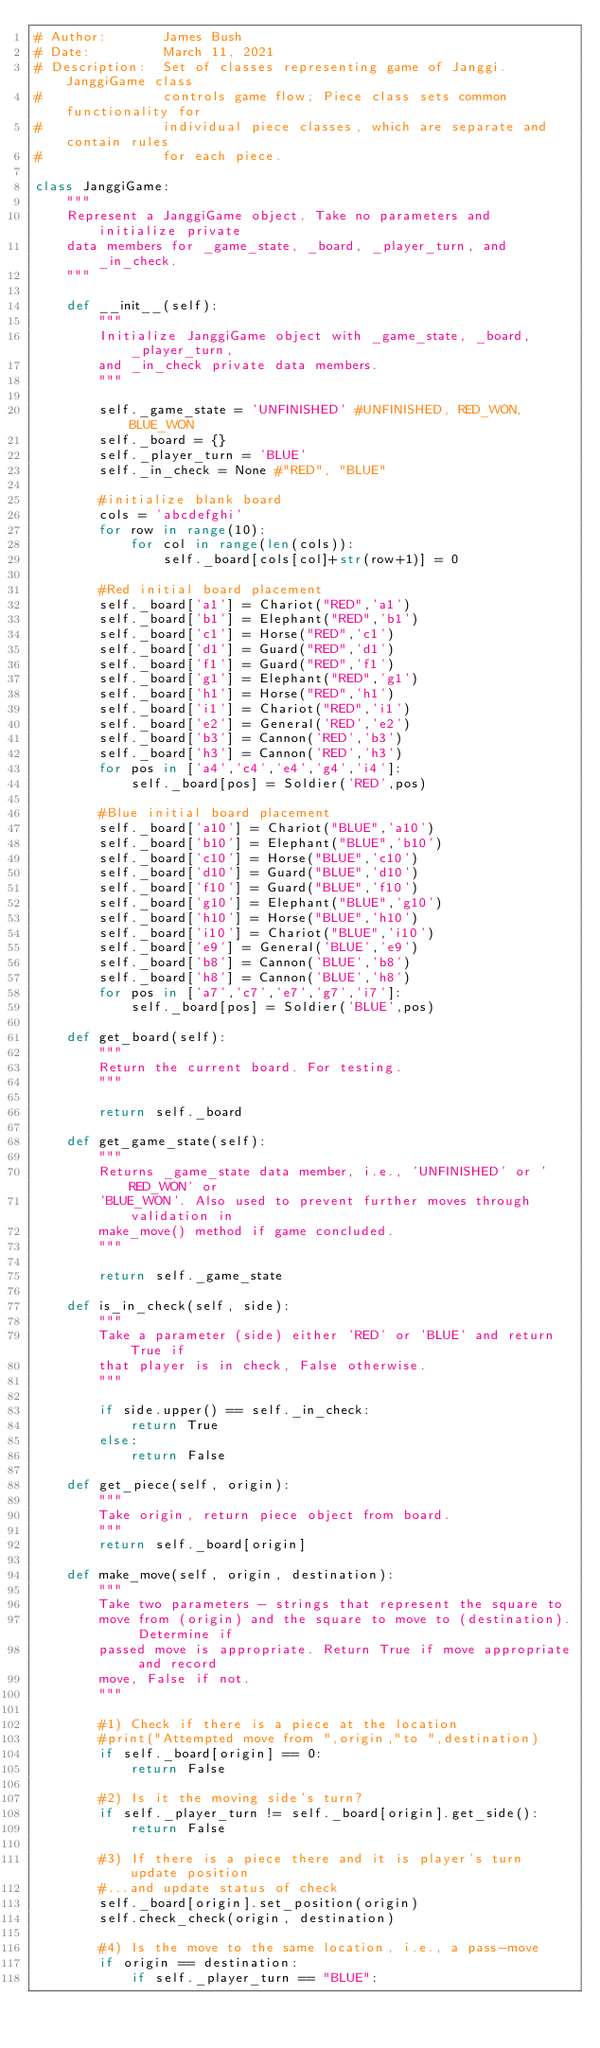Convert code to text. <code><loc_0><loc_0><loc_500><loc_500><_Python_># Author:       James Bush
# Date:         March 11, 2021
# Description:  Set of classes representing game of Janggi. JanggiGame class
#               controls game flow; Piece class sets common functionality for
#               individual piece classes, which are separate and contain rules
#               for each piece.

class JanggiGame:
    """
    Represent a JanggiGame object. Take no parameters and initialize private
    data members for _game_state, _board, _player_turn, and _in_check.
    """

    def __init__(self):
        """
        Initialize JanggiGame object with _game_state, _board, _player_turn,
        and _in_check private data members.
        """

        self._game_state = 'UNFINISHED' #UNFINISHED, RED_WON, BLUE_WON
        self._board = {}
        self._player_turn = 'BLUE'
        self._in_check = None #"RED", "BLUE"

        #initialize blank board
        cols = 'abcdefghi'
        for row in range(10):
            for col in range(len(cols)):
                self._board[cols[col]+str(row+1)] = 0

        #Red initial board placement
        self._board['a1'] = Chariot("RED",'a1')
        self._board['b1'] = Elephant("RED",'b1')
        self._board['c1'] = Horse("RED",'c1')
        self._board['d1'] = Guard("RED",'d1')
        self._board['f1'] = Guard("RED",'f1')
        self._board['g1'] = Elephant("RED",'g1')
        self._board['h1'] = Horse("RED",'h1')
        self._board['i1'] = Chariot("RED",'i1')
        self._board['e2'] = General('RED','e2')
        self._board['b3'] = Cannon('RED','b3')
        self._board['h3'] = Cannon('RED','h3')
        for pos in ['a4','c4','e4','g4','i4']:
            self._board[pos] = Soldier('RED',pos)

        #Blue initial board placement
        self._board['a10'] = Chariot("BLUE",'a10')
        self._board['b10'] = Elephant("BLUE",'b10')
        self._board['c10'] = Horse("BLUE",'c10')
        self._board['d10'] = Guard("BLUE",'d10')
        self._board['f10'] = Guard("BLUE",'f10')
        self._board['g10'] = Elephant("BLUE",'g10')
        self._board['h10'] = Horse("BLUE",'h10')
        self._board['i10'] = Chariot("BLUE",'i10')
        self._board['e9'] = General('BLUE','e9')
        self._board['b8'] = Cannon('BLUE','b8')
        self._board['h8'] = Cannon('BLUE','h8')
        for pos in ['a7','c7','e7','g7','i7']:
            self._board[pos] = Soldier('BLUE',pos)

    def get_board(self):
        """
        Return the current board. For testing.
        """

        return self._board

    def get_game_state(self):
        """
        Returns _game_state data member, i.e., 'UNFINISHED' or 'RED_WON' or
        'BLUE_WON'. Also used to prevent further moves through validation in
        make_move() method if game concluded.
        """

        return self._game_state

    def is_in_check(self, side):
        """
        Take a parameter (side) either 'RED' or 'BLUE' and return True if
        that player is in check, False otherwise.
        """

        if side.upper() == self._in_check:
            return True
        else:
            return False

    def get_piece(self, origin):
        """
        Take origin, return piece object from board.
        """
        return self._board[origin]

    def make_move(self, origin, destination):
        """
        Take two parameters - strings that represent the square to
        move from (origin) and the square to move to (destination). Determine if
        passed move is appropriate. Return True if move appropriate and record
        move, False if not.
        """

        #1) Check if there is a piece at the location
        #print("Attempted move from ",origin,"to ",destination)
        if self._board[origin] == 0:
            return False

        #2) Is it the moving side's turn?
        if self._player_turn != self._board[origin].get_side():
            return False

        #3) If there is a piece there and it is player's turn update position
        #...and update status of check
        self._board[origin].set_position(origin)
        self.check_check(origin, destination)

        #4) Is the move to the same location, i.e., a pass-move
        if origin == destination:
            if self._player_turn == "BLUE":</code> 